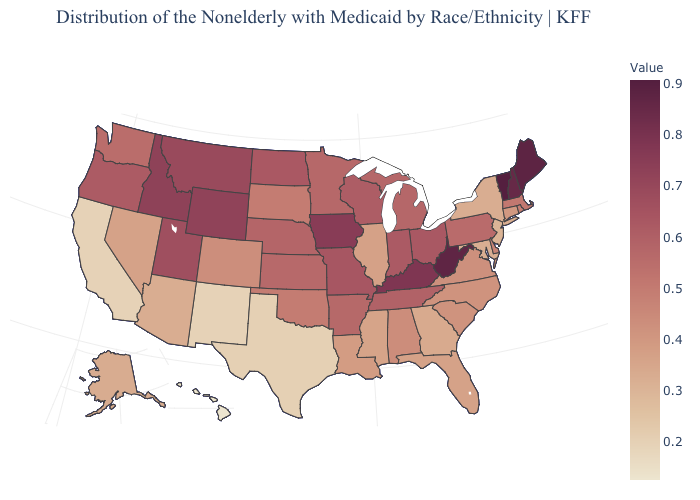Which states hav the highest value in the South?
Short answer required. West Virginia. Among the states that border Utah , does Idaho have the highest value?
Give a very brief answer. Yes. Does Nebraska have the highest value in the MidWest?
Keep it brief. No. Does Arizona have the highest value in the West?
Keep it brief. No. 